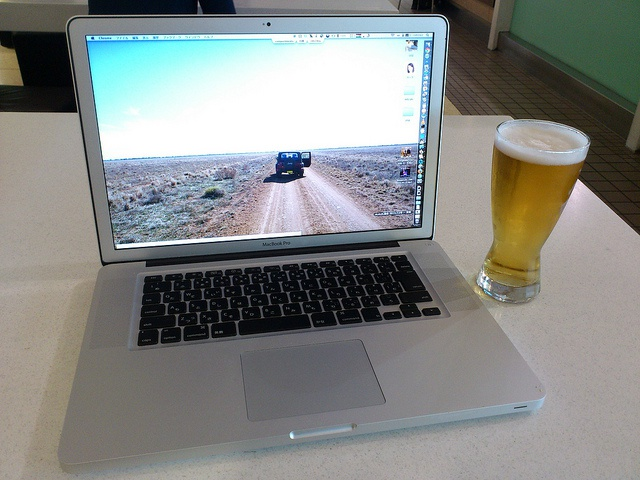Describe the objects in this image and their specific colors. I can see laptop in tan, gray, white, and black tones, wine glass in tan, olive, darkgray, and gray tones, cup in tan, olive, darkgray, and gray tones, and car in tan, navy, black, darkblue, and blue tones in this image. 